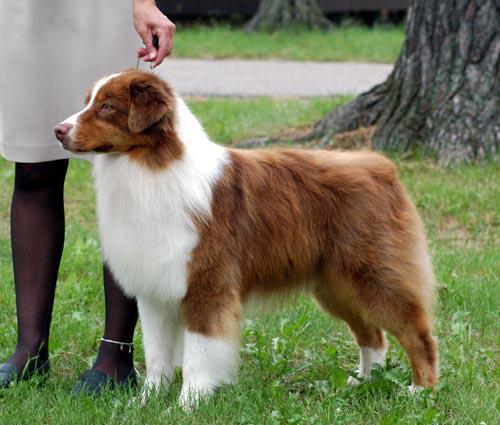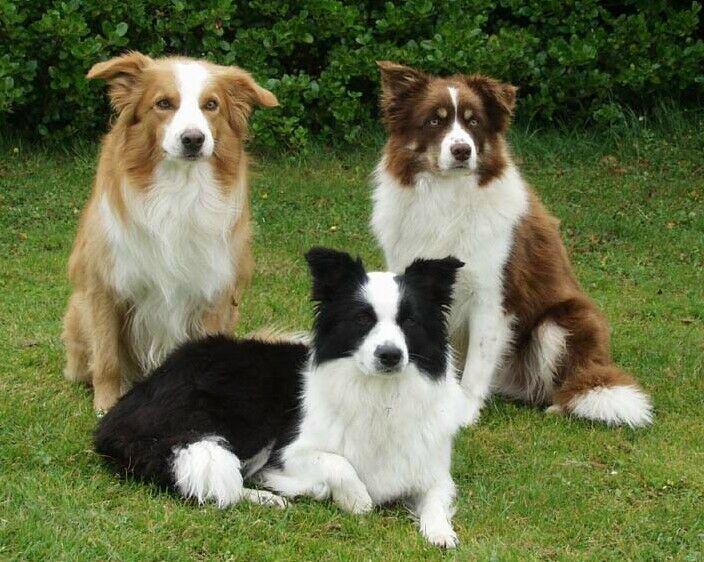The first image is the image on the left, the second image is the image on the right. For the images shown, is this caption "The dog in the image on the left is standing outside." true? Answer yes or no. Yes. The first image is the image on the left, the second image is the image on the right. For the images displayed, is the sentence "The lefthand image shows a non-standing, frontward-facing brown and white dog with non-erect erects." factually correct? Answer yes or no. No. 